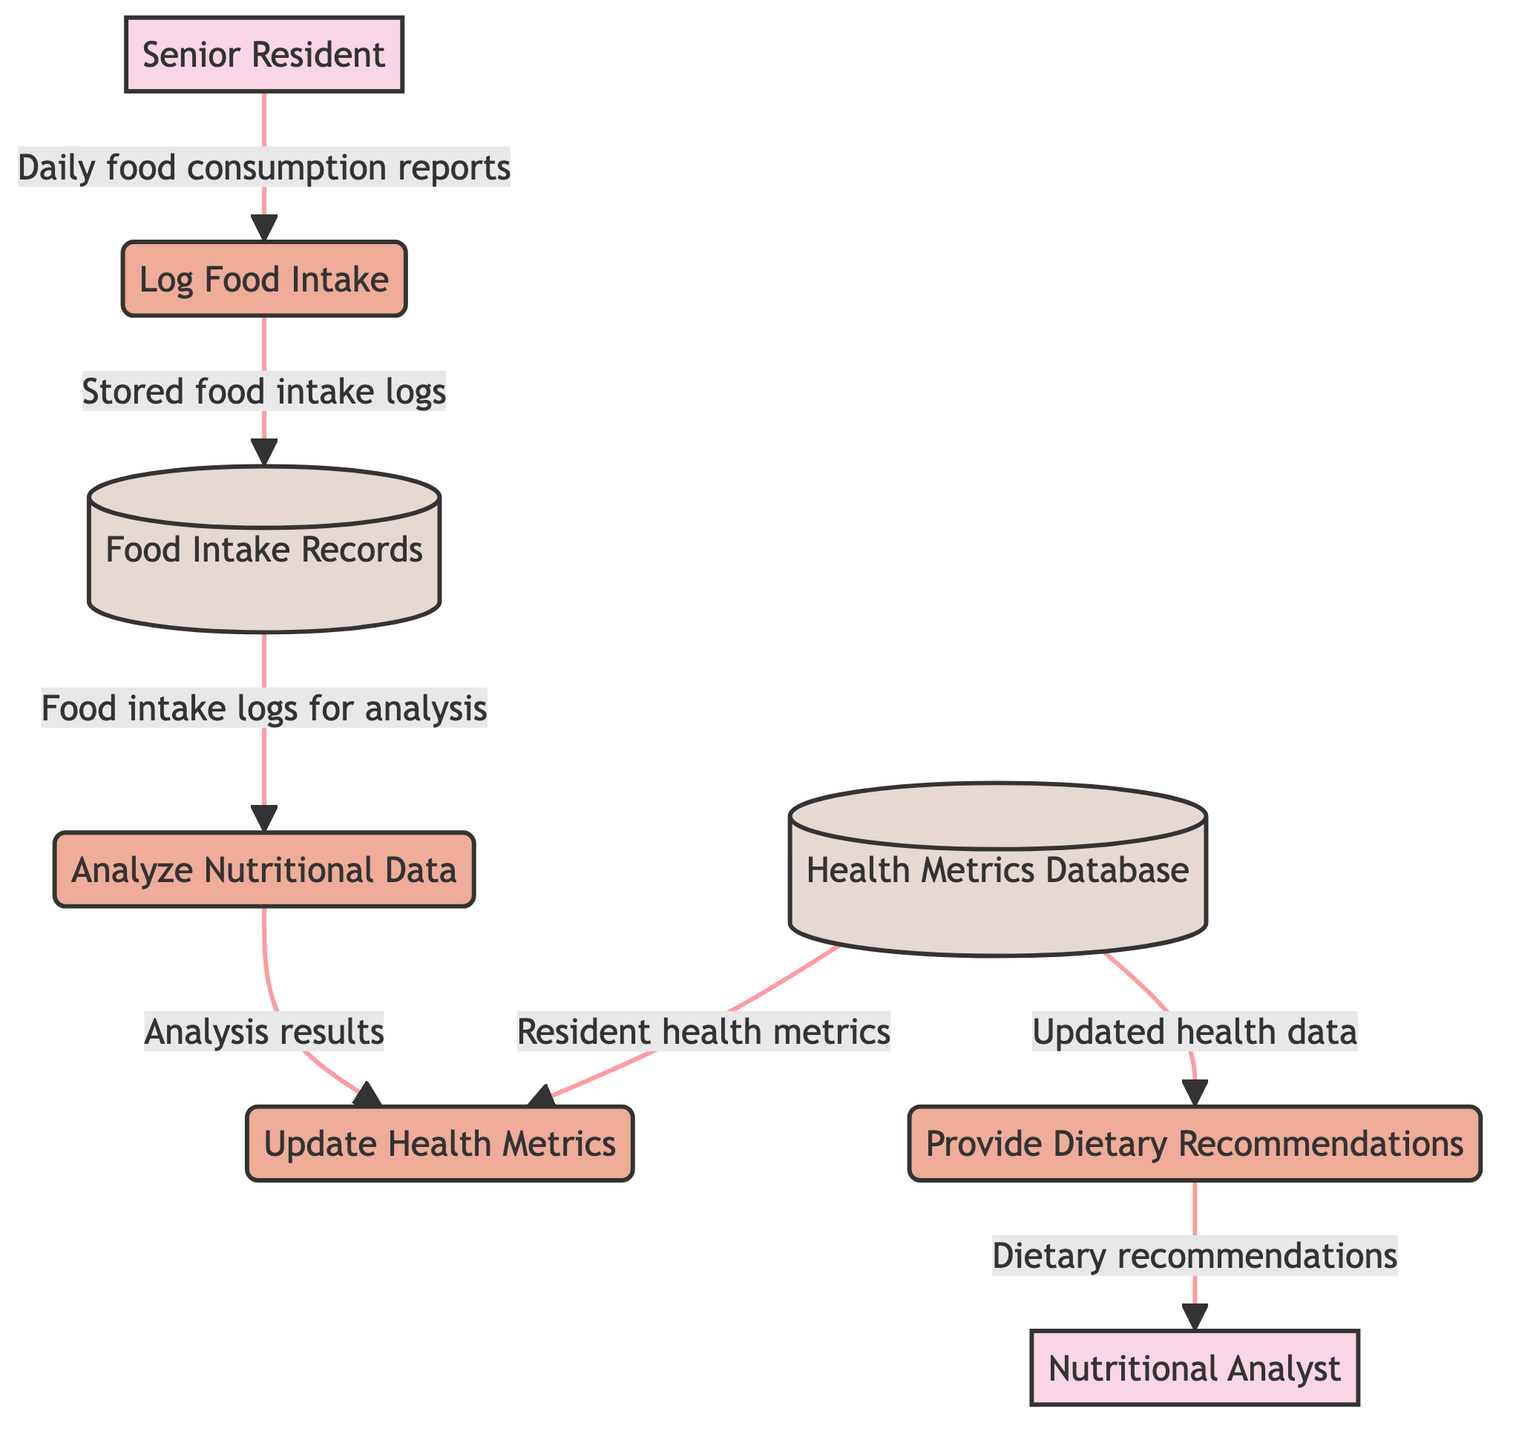What process is responsible for recording the daily food consumption of senior residents? The diagram indicates that the "Log Food Intake" process is responsible for recording the daily food consumption of senior residents.
Answer: Log Food Intake How many external entities are present in the diagram? The diagram shows two external entities: "Senior Resident" and "Nutritional Analyst." Therefore, the total number of external entities is two.
Answer: 2 Which data store receives logs from the Log Food Intake process? According to the diagram, the "Food Intake Records" data store receives stored food intake logs from the "Log Food Intake" process.
Answer: Food Intake Records What information does the Analyze Nutritional Data process use to conduct its analysis? The process "Analyze Nutritional Data" uses "Food intake logs for analysis" from the "Food Intake Records" data store to conduct its analysis.
Answer: Food intake logs for analysis Which process generates dietary recommendations based on updated health data? The diagram shows that the "Provide Dietary Recommendations" process generates dietary recommendations based on updated health data sourced from the "Health Metrics Database."
Answer: Provide Dietary Recommendations What are the two types of data stores shown in the diagram? The diagram displays two data stores: "Food Intake Records" and "Health Metrics Database." These are the only types of data stores represented therein.
Answer: Food Intake Records, Health Metrics Database What is the output of the Analyze Nutritional Data process? The "Analyze Nutritional Data" process outputs "Analysis results including recommendations and flagged issues" to the "Update Health Metrics" process.
Answer: Analysis results including recommendations and flagged issues What data does the Update Health Metrics process obtain from the Health Metrics Database? The "Update Health Metrics" process obtains "Resident health metrics" from the "Health Metrics Database" to perform its updates.
Answer: Resident health metrics How do the flows from the Health Metrics Database differ in their destinations? There are two flows from the "Health Metrics Database" — one goes to "Update Health Metrics" and the other goes to "Provide Dietary Recommendations," indicating that it serves multiple processes.
Answer: Two processes Which external entity provides daily food consumption reports? The external entity "Senior Resident" provides the daily food consumption reports to the "Log Food Intake" process.
Answer: Senior Resident 